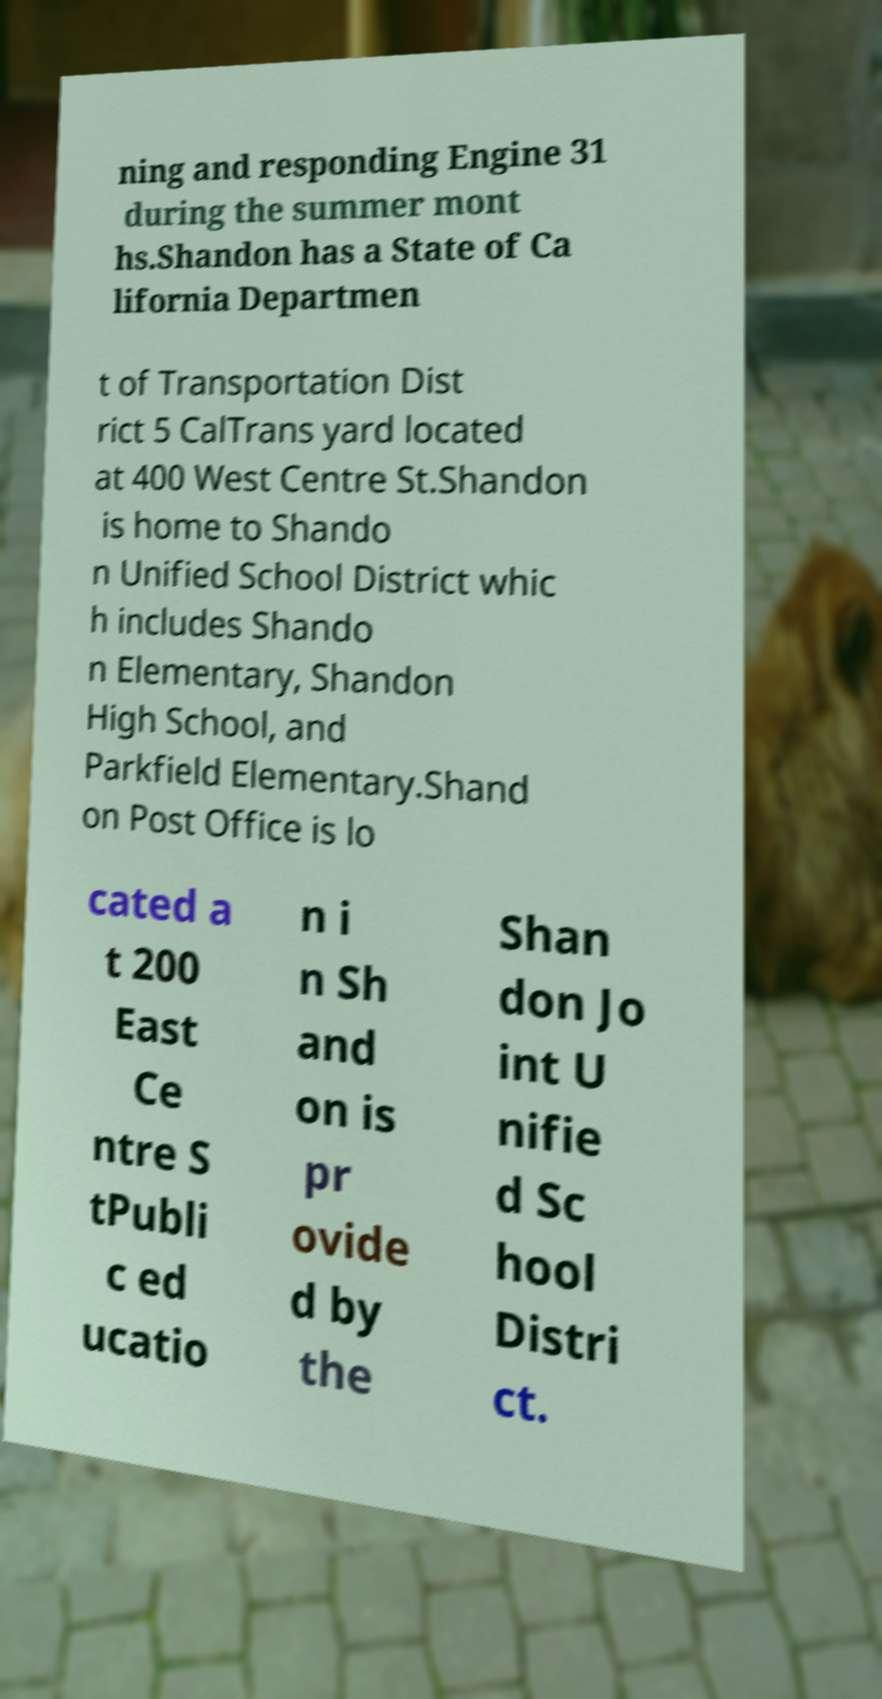Can you read and provide the text displayed in the image?This photo seems to have some interesting text. Can you extract and type it out for me? ning and responding Engine 31 during the summer mont hs.Shandon has a State of Ca lifornia Departmen t of Transportation Dist rict 5 CalTrans yard located at 400 West Centre St.Shandon is home to Shando n Unified School District whic h includes Shando n Elementary, Shandon High School, and Parkfield Elementary.Shand on Post Office is lo cated a t 200 East Ce ntre S tPubli c ed ucatio n i n Sh and on is pr ovide d by the Shan don Jo int U nifie d Sc hool Distri ct. 